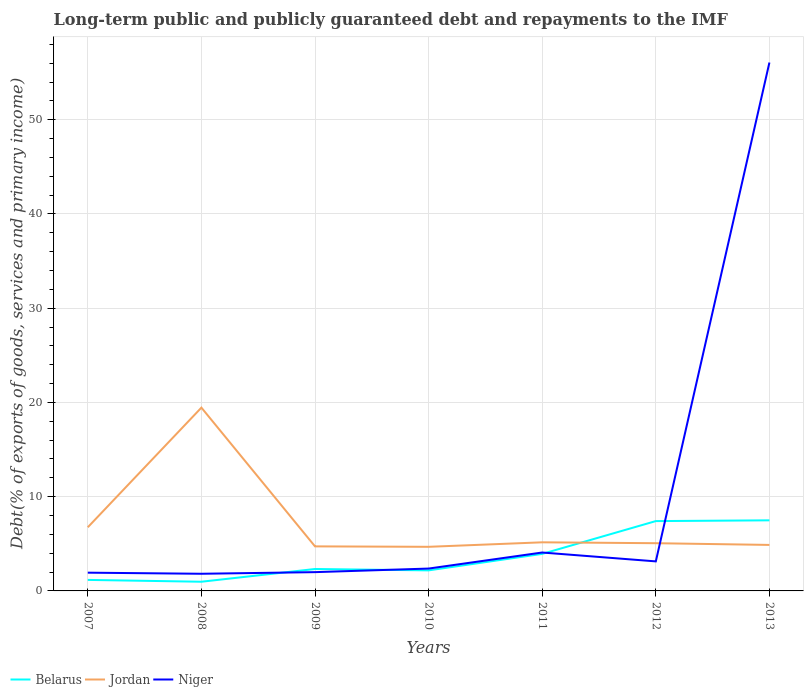How many different coloured lines are there?
Provide a short and direct response. 3. Does the line corresponding to Niger intersect with the line corresponding to Jordan?
Make the answer very short. Yes. Is the number of lines equal to the number of legend labels?
Make the answer very short. Yes. Across all years, what is the maximum debt and repayments in Niger?
Your answer should be very brief. 1.82. What is the total debt and repayments in Jordan in the graph?
Offer a terse response. 14.38. What is the difference between the highest and the second highest debt and repayments in Niger?
Provide a succinct answer. 54.25. What is the difference between the highest and the lowest debt and repayments in Belarus?
Make the answer very short. 3. Is the debt and repayments in Niger strictly greater than the debt and repayments in Belarus over the years?
Offer a terse response. No. How many years are there in the graph?
Your answer should be compact. 7. What is the difference between two consecutive major ticks on the Y-axis?
Provide a short and direct response. 10. Does the graph contain grids?
Offer a very short reply. Yes. Where does the legend appear in the graph?
Give a very brief answer. Bottom left. How many legend labels are there?
Ensure brevity in your answer.  3. What is the title of the graph?
Your response must be concise. Long-term public and publicly guaranteed debt and repayments to the IMF. What is the label or title of the Y-axis?
Ensure brevity in your answer.  Debt(% of exports of goods, services and primary income). What is the Debt(% of exports of goods, services and primary income) in Belarus in 2007?
Your answer should be compact. 1.17. What is the Debt(% of exports of goods, services and primary income) of Jordan in 2007?
Offer a very short reply. 6.75. What is the Debt(% of exports of goods, services and primary income) in Niger in 2007?
Provide a short and direct response. 1.94. What is the Debt(% of exports of goods, services and primary income) of Belarus in 2008?
Your response must be concise. 0.98. What is the Debt(% of exports of goods, services and primary income) of Jordan in 2008?
Offer a very short reply. 19.45. What is the Debt(% of exports of goods, services and primary income) in Niger in 2008?
Your answer should be very brief. 1.82. What is the Debt(% of exports of goods, services and primary income) in Belarus in 2009?
Ensure brevity in your answer.  2.33. What is the Debt(% of exports of goods, services and primary income) in Jordan in 2009?
Ensure brevity in your answer.  4.73. What is the Debt(% of exports of goods, services and primary income) in Niger in 2009?
Offer a very short reply. 1.99. What is the Debt(% of exports of goods, services and primary income) in Belarus in 2010?
Offer a very short reply. 2.18. What is the Debt(% of exports of goods, services and primary income) of Jordan in 2010?
Ensure brevity in your answer.  4.68. What is the Debt(% of exports of goods, services and primary income) of Niger in 2010?
Make the answer very short. 2.37. What is the Debt(% of exports of goods, services and primary income) in Belarus in 2011?
Make the answer very short. 3.93. What is the Debt(% of exports of goods, services and primary income) of Jordan in 2011?
Your response must be concise. 5.16. What is the Debt(% of exports of goods, services and primary income) in Niger in 2011?
Your answer should be very brief. 4.08. What is the Debt(% of exports of goods, services and primary income) in Belarus in 2012?
Provide a succinct answer. 7.41. What is the Debt(% of exports of goods, services and primary income) of Jordan in 2012?
Keep it short and to the point. 5.06. What is the Debt(% of exports of goods, services and primary income) in Niger in 2012?
Offer a terse response. 3.13. What is the Debt(% of exports of goods, services and primary income) in Belarus in 2013?
Provide a succinct answer. 7.49. What is the Debt(% of exports of goods, services and primary income) of Jordan in 2013?
Your answer should be very brief. 4.88. What is the Debt(% of exports of goods, services and primary income) of Niger in 2013?
Make the answer very short. 56.07. Across all years, what is the maximum Debt(% of exports of goods, services and primary income) of Belarus?
Make the answer very short. 7.49. Across all years, what is the maximum Debt(% of exports of goods, services and primary income) of Jordan?
Ensure brevity in your answer.  19.45. Across all years, what is the maximum Debt(% of exports of goods, services and primary income) of Niger?
Make the answer very short. 56.07. Across all years, what is the minimum Debt(% of exports of goods, services and primary income) of Belarus?
Offer a terse response. 0.98. Across all years, what is the minimum Debt(% of exports of goods, services and primary income) of Jordan?
Provide a short and direct response. 4.68. Across all years, what is the minimum Debt(% of exports of goods, services and primary income) of Niger?
Make the answer very short. 1.82. What is the total Debt(% of exports of goods, services and primary income) in Belarus in the graph?
Your answer should be compact. 25.48. What is the total Debt(% of exports of goods, services and primary income) of Jordan in the graph?
Ensure brevity in your answer.  50.71. What is the total Debt(% of exports of goods, services and primary income) in Niger in the graph?
Give a very brief answer. 71.4. What is the difference between the Debt(% of exports of goods, services and primary income) of Belarus in 2007 and that in 2008?
Ensure brevity in your answer.  0.19. What is the difference between the Debt(% of exports of goods, services and primary income) in Jordan in 2007 and that in 2008?
Make the answer very short. -12.7. What is the difference between the Debt(% of exports of goods, services and primary income) of Niger in 2007 and that in 2008?
Offer a very short reply. 0.12. What is the difference between the Debt(% of exports of goods, services and primary income) in Belarus in 2007 and that in 2009?
Your response must be concise. -1.16. What is the difference between the Debt(% of exports of goods, services and primary income) of Jordan in 2007 and that in 2009?
Offer a terse response. 2.03. What is the difference between the Debt(% of exports of goods, services and primary income) of Niger in 2007 and that in 2009?
Keep it short and to the point. -0.06. What is the difference between the Debt(% of exports of goods, services and primary income) in Belarus in 2007 and that in 2010?
Give a very brief answer. -1.01. What is the difference between the Debt(% of exports of goods, services and primary income) in Jordan in 2007 and that in 2010?
Offer a very short reply. 2.07. What is the difference between the Debt(% of exports of goods, services and primary income) in Niger in 2007 and that in 2010?
Offer a terse response. -0.44. What is the difference between the Debt(% of exports of goods, services and primary income) in Belarus in 2007 and that in 2011?
Keep it short and to the point. -2.76. What is the difference between the Debt(% of exports of goods, services and primary income) of Jordan in 2007 and that in 2011?
Make the answer very short. 1.6. What is the difference between the Debt(% of exports of goods, services and primary income) in Niger in 2007 and that in 2011?
Give a very brief answer. -2.14. What is the difference between the Debt(% of exports of goods, services and primary income) of Belarus in 2007 and that in 2012?
Your response must be concise. -6.24. What is the difference between the Debt(% of exports of goods, services and primary income) of Jordan in 2007 and that in 2012?
Your answer should be compact. 1.69. What is the difference between the Debt(% of exports of goods, services and primary income) of Niger in 2007 and that in 2012?
Offer a very short reply. -1.2. What is the difference between the Debt(% of exports of goods, services and primary income) of Belarus in 2007 and that in 2013?
Offer a very short reply. -6.32. What is the difference between the Debt(% of exports of goods, services and primary income) of Jordan in 2007 and that in 2013?
Your response must be concise. 1.87. What is the difference between the Debt(% of exports of goods, services and primary income) of Niger in 2007 and that in 2013?
Give a very brief answer. -54.13. What is the difference between the Debt(% of exports of goods, services and primary income) of Belarus in 2008 and that in 2009?
Give a very brief answer. -1.35. What is the difference between the Debt(% of exports of goods, services and primary income) in Jordan in 2008 and that in 2009?
Provide a succinct answer. 14.72. What is the difference between the Debt(% of exports of goods, services and primary income) in Niger in 2008 and that in 2009?
Provide a succinct answer. -0.17. What is the difference between the Debt(% of exports of goods, services and primary income) of Belarus in 2008 and that in 2010?
Provide a succinct answer. -1.21. What is the difference between the Debt(% of exports of goods, services and primary income) of Jordan in 2008 and that in 2010?
Keep it short and to the point. 14.77. What is the difference between the Debt(% of exports of goods, services and primary income) in Niger in 2008 and that in 2010?
Offer a terse response. -0.55. What is the difference between the Debt(% of exports of goods, services and primary income) of Belarus in 2008 and that in 2011?
Ensure brevity in your answer.  -2.96. What is the difference between the Debt(% of exports of goods, services and primary income) of Jordan in 2008 and that in 2011?
Offer a terse response. 14.29. What is the difference between the Debt(% of exports of goods, services and primary income) in Niger in 2008 and that in 2011?
Keep it short and to the point. -2.26. What is the difference between the Debt(% of exports of goods, services and primary income) in Belarus in 2008 and that in 2012?
Offer a terse response. -6.44. What is the difference between the Debt(% of exports of goods, services and primary income) in Jordan in 2008 and that in 2012?
Offer a very short reply. 14.38. What is the difference between the Debt(% of exports of goods, services and primary income) of Niger in 2008 and that in 2012?
Your answer should be compact. -1.31. What is the difference between the Debt(% of exports of goods, services and primary income) in Belarus in 2008 and that in 2013?
Ensure brevity in your answer.  -6.52. What is the difference between the Debt(% of exports of goods, services and primary income) in Jordan in 2008 and that in 2013?
Your response must be concise. 14.57. What is the difference between the Debt(% of exports of goods, services and primary income) in Niger in 2008 and that in 2013?
Keep it short and to the point. -54.25. What is the difference between the Debt(% of exports of goods, services and primary income) in Belarus in 2009 and that in 2010?
Give a very brief answer. 0.15. What is the difference between the Debt(% of exports of goods, services and primary income) of Jordan in 2009 and that in 2010?
Provide a short and direct response. 0.05. What is the difference between the Debt(% of exports of goods, services and primary income) in Niger in 2009 and that in 2010?
Make the answer very short. -0.38. What is the difference between the Debt(% of exports of goods, services and primary income) of Belarus in 2009 and that in 2011?
Offer a terse response. -1.6. What is the difference between the Debt(% of exports of goods, services and primary income) of Jordan in 2009 and that in 2011?
Give a very brief answer. -0.43. What is the difference between the Debt(% of exports of goods, services and primary income) in Niger in 2009 and that in 2011?
Make the answer very short. -2.08. What is the difference between the Debt(% of exports of goods, services and primary income) in Belarus in 2009 and that in 2012?
Your response must be concise. -5.08. What is the difference between the Debt(% of exports of goods, services and primary income) of Jordan in 2009 and that in 2012?
Your answer should be compact. -0.34. What is the difference between the Debt(% of exports of goods, services and primary income) of Niger in 2009 and that in 2012?
Offer a very short reply. -1.14. What is the difference between the Debt(% of exports of goods, services and primary income) of Belarus in 2009 and that in 2013?
Your answer should be compact. -5.16. What is the difference between the Debt(% of exports of goods, services and primary income) in Jordan in 2009 and that in 2013?
Your answer should be compact. -0.15. What is the difference between the Debt(% of exports of goods, services and primary income) of Niger in 2009 and that in 2013?
Keep it short and to the point. -54.08. What is the difference between the Debt(% of exports of goods, services and primary income) in Belarus in 2010 and that in 2011?
Offer a terse response. -1.75. What is the difference between the Debt(% of exports of goods, services and primary income) in Jordan in 2010 and that in 2011?
Offer a very short reply. -0.48. What is the difference between the Debt(% of exports of goods, services and primary income) of Niger in 2010 and that in 2011?
Ensure brevity in your answer.  -1.7. What is the difference between the Debt(% of exports of goods, services and primary income) in Belarus in 2010 and that in 2012?
Give a very brief answer. -5.23. What is the difference between the Debt(% of exports of goods, services and primary income) in Jordan in 2010 and that in 2012?
Ensure brevity in your answer.  -0.38. What is the difference between the Debt(% of exports of goods, services and primary income) of Niger in 2010 and that in 2012?
Offer a very short reply. -0.76. What is the difference between the Debt(% of exports of goods, services and primary income) of Belarus in 2010 and that in 2013?
Ensure brevity in your answer.  -5.31. What is the difference between the Debt(% of exports of goods, services and primary income) of Jordan in 2010 and that in 2013?
Offer a terse response. -0.2. What is the difference between the Debt(% of exports of goods, services and primary income) of Niger in 2010 and that in 2013?
Your answer should be very brief. -53.7. What is the difference between the Debt(% of exports of goods, services and primary income) in Belarus in 2011 and that in 2012?
Keep it short and to the point. -3.48. What is the difference between the Debt(% of exports of goods, services and primary income) in Jordan in 2011 and that in 2012?
Your answer should be compact. 0.09. What is the difference between the Debt(% of exports of goods, services and primary income) in Niger in 2011 and that in 2012?
Offer a very short reply. 0.94. What is the difference between the Debt(% of exports of goods, services and primary income) of Belarus in 2011 and that in 2013?
Offer a terse response. -3.56. What is the difference between the Debt(% of exports of goods, services and primary income) in Jordan in 2011 and that in 2013?
Ensure brevity in your answer.  0.28. What is the difference between the Debt(% of exports of goods, services and primary income) of Niger in 2011 and that in 2013?
Provide a short and direct response. -51.99. What is the difference between the Debt(% of exports of goods, services and primary income) in Belarus in 2012 and that in 2013?
Offer a terse response. -0.08. What is the difference between the Debt(% of exports of goods, services and primary income) of Jordan in 2012 and that in 2013?
Make the answer very short. 0.18. What is the difference between the Debt(% of exports of goods, services and primary income) of Niger in 2012 and that in 2013?
Ensure brevity in your answer.  -52.93. What is the difference between the Debt(% of exports of goods, services and primary income) of Belarus in 2007 and the Debt(% of exports of goods, services and primary income) of Jordan in 2008?
Provide a succinct answer. -18.28. What is the difference between the Debt(% of exports of goods, services and primary income) in Belarus in 2007 and the Debt(% of exports of goods, services and primary income) in Niger in 2008?
Provide a short and direct response. -0.65. What is the difference between the Debt(% of exports of goods, services and primary income) of Jordan in 2007 and the Debt(% of exports of goods, services and primary income) of Niger in 2008?
Keep it short and to the point. 4.93. What is the difference between the Debt(% of exports of goods, services and primary income) of Belarus in 2007 and the Debt(% of exports of goods, services and primary income) of Jordan in 2009?
Provide a succinct answer. -3.56. What is the difference between the Debt(% of exports of goods, services and primary income) of Belarus in 2007 and the Debt(% of exports of goods, services and primary income) of Niger in 2009?
Give a very brief answer. -0.82. What is the difference between the Debt(% of exports of goods, services and primary income) of Jordan in 2007 and the Debt(% of exports of goods, services and primary income) of Niger in 2009?
Provide a short and direct response. 4.76. What is the difference between the Debt(% of exports of goods, services and primary income) of Belarus in 2007 and the Debt(% of exports of goods, services and primary income) of Jordan in 2010?
Your response must be concise. -3.51. What is the difference between the Debt(% of exports of goods, services and primary income) of Belarus in 2007 and the Debt(% of exports of goods, services and primary income) of Niger in 2010?
Ensure brevity in your answer.  -1.2. What is the difference between the Debt(% of exports of goods, services and primary income) in Jordan in 2007 and the Debt(% of exports of goods, services and primary income) in Niger in 2010?
Offer a terse response. 4.38. What is the difference between the Debt(% of exports of goods, services and primary income) of Belarus in 2007 and the Debt(% of exports of goods, services and primary income) of Jordan in 2011?
Offer a terse response. -3.99. What is the difference between the Debt(% of exports of goods, services and primary income) of Belarus in 2007 and the Debt(% of exports of goods, services and primary income) of Niger in 2011?
Provide a short and direct response. -2.91. What is the difference between the Debt(% of exports of goods, services and primary income) of Jordan in 2007 and the Debt(% of exports of goods, services and primary income) of Niger in 2011?
Your answer should be compact. 2.68. What is the difference between the Debt(% of exports of goods, services and primary income) in Belarus in 2007 and the Debt(% of exports of goods, services and primary income) in Jordan in 2012?
Your response must be concise. -3.9. What is the difference between the Debt(% of exports of goods, services and primary income) in Belarus in 2007 and the Debt(% of exports of goods, services and primary income) in Niger in 2012?
Give a very brief answer. -1.97. What is the difference between the Debt(% of exports of goods, services and primary income) of Jordan in 2007 and the Debt(% of exports of goods, services and primary income) of Niger in 2012?
Provide a short and direct response. 3.62. What is the difference between the Debt(% of exports of goods, services and primary income) in Belarus in 2007 and the Debt(% of exports of goods, services and primary income) in Jordan in 2013?
Offer a very short reply. -3.71. What is the difference between the Debt(% of exports of goods, services and primary income) in Belarus in 2007 and the Debt(% of exports of goods, services and primary income) in Niger in 2013?
Provide a short and direct response. -54.9. What is the difference between the Debt(% of exports of goods, services and primary income) of Jordan in 2007 and the Debt(% of exports of goods, services and primary income) of Niger in 2013?
Your answer should be compact. -49.32. What is the difference between the Debt(% of exports of goods, services and primary income) of Belarus in 2008 and the Debt(% of exports of goods, services and primary income) of Jordan in 2009?
Offer a terse response. -3.75. What is the difference between the Debt(% of exports of goods, services and primary income) in Belarus in 2008 and the Debt(% of exports of goods, services and primary income) in Niger in 2009?
Your answer should be compact. -1.02. What is the difference between the Debt(% of exports of goods, services and primary income) in Jordan in 2008 and the Debt(% of exports of goods, services and primary income) in Niger in 2009?
Your answer should be very brief. 17.46. What is the difference between the Debt(% of exports of goods, services and primary income) of Belarus in 2008 and the Debt(% of exports of goods, services and primary income) of Jordan in 2010?
Provide a succinct answer. -3.71. What is the difference between the Debt(% of exports of goods, services and primary income) of Belarus in 2008 and the Debt(% of exports of goods, services and primary income) of Niger in 2010?
Give a very brief answer. -1.4. What is the difference between the Debt(% of exports of goods, services and primary income) in Jordan in 2008 and the Debt(% of exports of goods, services and primary income) in Niger in 2010?
Your answer should be very brief. 17.08. What is the difference between the Debt(% of exports of goods, services and primary income) of Belarus in 2008 and the Debt(% of exports of goods, services and primary income) of Jordan in 2011?
Provide a succinct answer. -4.18. What is the difference between the Debt(% of exports of goods, services and primary income) of Belarus in 2008 and the Debt(% of exports of goods, services and primary income) of Niger in 2011?
Offer a very short reply. -3.1. What is the difference between the Debt(% of exports of goods, services and primary income) of Jordan in 2008 and the Debt(% of exports of goods, services and primary income) of Niger in 2011?
Your response must be concise. 15.37. What is the difference between the Debt(% of exports of goods, services and primary income) of Belarus in 2008 and the Debt(% of exports of goods, services and primary income) of Jordan in 2012?
Keep it short and to the point. -4.09. What is the difference between the Debt(% of exports of goods, services and primary income) in Belarus in 2008 and the Debt(% of exports of goods, services and primary income) in Niger in 2012?
Offer a terse response. -2.16. What is the difference between the Debt(% of exports of goods, services and primary income) in Jordan in 2008 and the Debt(% of exports of goods, services and primary income) in Niger in 2012?
Keep it short and to the point. 16.31. What is the difference between the Debt(% of exports of goods, services and primary income) in Belarus in 2008 and the Debt(% of exports of goods, services and primary income) in Jordan in 2013?
Offer a very short reply. -3.91. What is the difference between the Debt(% of exports of goods, services and primary income) of Belarus in 2008 and the Debt(% of exports of goods, services and primary income) of Niger in 2013?
Keep it short and to the point. -55.09. What is the difference between the Debt(% of exports of goods, services and primary income) in Jordan in 2008 and the Debt(% of exports of goods, services and primary income) in Niger in 2013?
Provide a short and direct response. -36.62. What is the difference between the Debt(% of exports of goods, services and primary income) of Belarus in 2009 and the Debt(% of exports of goods, services and primary income) of Jordan in 2010?
Provide a succinct answer. -2.35. What is the difference between the Debt(% of exports of goods, services and primary income) in Belarus in 2009 and the Debt(% of exports of goods, services and primary income) in Niger in 2010?
Offer a terse response. -0.05. What is the difference between the Debt(% of exports of goods, services and primary income) in Jordan in 2009 and the Debt(% of exports of goods, services and primary income) in Niger in 2010?
Make the answer very short. 2.35. What is the difference between the Debt(% of exports of goods, services and primary income) in Belarus in 2009 and the Debt(% of exports of goods, services and primary income) in Jordan in 2011?
Your answer should be compact. -2.83. What is the difference between the Debt(% of exports of goods, services and primary income) of Belarus in 2009 and the Debt(% of exports of goods, services and primary income) of Niger in 2011?
Give a very brief answer. -1.75. What is the difference between the Debt(% of exports of goods, services and primary income) of Jordan in 2009 and the Debt(% of exports of goods, services and primary income) of Niger in 2011?
Your response must be concise. 0.65. What is the difference between the Debt(% of exports of goods, services and primary income) of Belarus in 2009 and the Debt(% of exports of goods, services and primary income) of Jordan in 2012?
Provide a succinct answer. -2.74. What is the difference between the Debt(% of exports of goods, services and primary income) of Belarus in 2009 and the Debt(% of exports of goods, services and primary income) of Niger in 2012?
Your answer should be compact. -0.81. What is the difference between the Debt(% of exports of goods, services and primary income) of Jordan in 2009 and the Debt(% of exports of goods, services and primary income) of Niger in 2012?
Make the answer very short. 1.59. What is the difference between the Debt(% of exports of goods, services and primary income) of Belarus in 2009 and the Debt(% of exports of goods, services and primary income) of Jordan in 2013?
Offer a terse response. -2.56. What is the difference between the Debt(% of exports of goods, services and primary income) of Belarus in 2009 and the Debt(% of exports of goods, services and primary income) of Niger in 2013?
Make the answer very short. -53.74. What is the difference between the Debt(% of exports of goods, services and primary income) of Jordan in 2009 and the Debt(% of exports of goods, services and primary income) of Niger in 2013?
Give a very brief answer. -51.34. What is the difference between the Debt(% of exports of goods, services and primary income) in Belarus in 2010 and the Debt(% of exports of goods, services and primary income) in Jordan in 2011?
Provide a short and direct response. -2.98. What is the difference between the Debt(% of exports of goods, services and primary income) in Belarus in 2010 and the Debt(% of exports of goods, services and primary income) in Niger in 2011?
Your response must be concise. -1.89. What is the difference between the Debt(% of exports of goods, services and primary income) of Jordan in 2010 and the Debt(% of exports of goods, services and primary income) of Niger in 2011?
Offer a very short reply. 0.6. What is the difference between the Debt(% of exports of goods, services and primary income) of Belarus in 2010 and the Debt(% of exports of goods, services and primary income) of Jordan in 2012?
Offer a terse response. -2.88. What is the difference between the Debt(% of exports of goods, services and primary income) in Belarus in 2010 and the Debt(% of exports of goods, services and primary income) in Niger in 2012?
Ensure brevity in your answer.  -0.95. What is the difference between the Debt(% of exports of goods, services and primary income) of Jordan in 2010 and the Debt(% of exports of goods, services and primary income) of Niger in 2012?
Your answer should be compact. 1.55. What is the difference between the Debt(% of exports of goods, services and primary income) in Belarus in 2010 and the Debt(% of exports of goods, services and primary income) in Jordan in 2013?
Your response must be concise. -2.7. What is the difference between the Debt(% of exports of goods, services and primary income) in Belarus in 2010 and the Debt(% of exports of goods, services and primary income) in Niger in 2013?
Provide a succinct answer. -53.89. What is the difference between the Debt(% of exports of goods, services and primary income) of Jordan in 2010 and the Debt(% of exports of goods, services and primary income) of Niger in 2013?
Your answer should be compact. -51.39. What is the difference between the Debt(% of exports of goods, services and primary income) of Belarus in 2011 and the Debt(% of exports of goods, services and primary income) of Jordan in 2012?
Ensure brevity in your answer.  -1.13. What is the difference between the Debt(% of exports of goods, services and primary income) in Belarus in 2011 and the Debt(% of exports of goods, services and primary income) in Niger in 2012?
Provide a succinct answer. 0.8. What is the difference between the Debt(% of exports of goods, services and primary income) in Jordan in 2011 and the Debt(% of exports of goods, services and primary income) in Niger in 2012?
Give a very brief answer. 2.02. What is the difference between the Debt(% of exports of goods, services and primary income) in Belarus in 2011 and the Debt(% of exports of goods, services and primary income) in Jordan in 2013?
Provide a short and direct response. -0.95. What is the difference between the Debt(% of exports of goods, services and primary income) in Belarus in 2011 and the Debt(% of exports of goods, services and primary income) in Niger in 2013?
Make the answer very short. -52.14. What is the difference between the Debt(% of exports of goods, services and primary income) in Jordan in 2011 and the Debt(% of exports of goods, services and primary income) in Niger in 2013?
Keep it short and to the point. -50.91. What is the difference between the Debt(% of exports of goods, services and primary income) in Belarus in 2012 and the Debt(% of exports of goods, services and primary income) in Jordan in 2013?
Your answer should be compact. 2.53. What is the difference between the Debt(% of exports of goods, services and primary income) in Belarus in 2012 and the Debt(% of exports of goods, services and primary income) in Niger in 2013?
Offer a very short reply. -48.66. What is the difference between the Debt(% of exports of goods, services and primary income) of Jordan in 2012 and the Debt(% of exports of goods, services and primary income) of Niger in 2013?
Your response must be concise. -51. What is the average Debt(% of exports of goods, services and primary income) in Belarus per year?
Your answer should be compact. 3.64. What is the average Debt(% of exports of goods, services and primary income) in Jordan per year?
Offer a very short reply. 7.24. What is the average Debt(% of exports of goods, services and primary income) in Niger per year?
Keep it short and to the point. 10.2. In the year 2007, what is the difference between the Debt(% of exports of goods, services and primary income) of Belarus and Debt(% of exports of goods, services and primary income) of Jordan?
Your answer should be very brief. -5.58. In the year 2007, what is the difference between the Debt(% of exports of goods, services and primary income) in Belarus and Debt(% of exports of goods, services and primary income) in Niger?
Your answer should be very brief. -0.77. In the year 2007, what is the difference between the Debt(% of exports of goods, services and primary income) of Jordan and Debt(% of exports of goods, services and primary income) of Niger?
Offer a terse response. 4.82. In the year 2008, what is the difference between the Debt(% of exports of goods, services and primary income) in Belarus and Debt(% of exports of goods, services and primary income) in Jordan?
Offer a terse response. -18.47. In the year 2008, what is the difference between the Debt(% of exports of goods, services and primary income) of Belarus and Debt(% of exports of goods, services and primary income) of Niger?
Provide a short and direct response. -0.84. In the year 2008, what is the difference between the Debt(% of exports of goods, services and primary income) in Jordan and Debt(% of exports of goods, services and primary income) in Niger?
Your answer should be compact. 17.63. In the year 2009, what is the difference between the Debt(% of exports of goods, services and primary income) in Belarus and Debt(% of exports of goods, services and primary income) in Jordan?
Provide a short and direct response. -2.4. In the year 2009, what is the difference between the Debt(% of exports of goods, services and primary income) in Belarus and Debt(% of exports of goods, services and primary income) in Niger?
Keep it short and to the point. 0.33. In the year 2009, what is the difference between the Debt(% of exports of goods, services and primary income) in Jordan and Debt(% of exports of goods, services and primary income) in Niger?
Your answer should be compact. 2.73. In the year 2010, what is the difference between the Debt(% of exports of goods, services and primary income) of Belarus and Debt(% of exports of goods, services and primary income) of Jordan?
Your response must be concise. -2.5. In the year 2010, what is the difference between the Debt(% of exports of goods, services and primary income) in Belarus and Debt(% of exports of goods, services and primary income) in Niger?
Provide a succinct answer. -0.19. In the year 2010, what is the difference between the Debt(% of exports of goods, services and primary income) of Jordan and Debt(% of exports of goods, services and primary income) of Niger?
Your response must be concise. 2.31. In the year 2011, what is the difference between the Debt(% of exports of goods, services and primary income) of Belarus and Debt(% of exports of goods, services and primary income) of Jordan?
Make the answer very short. -1.23. In the year 2011, what is the difference between the Debt(% of exports of goods, services and primary income) of Belarus and Debt(% of exports of goods, services and primary income) of Niger?
Keep it short and to the point. -0.15. In the year 2011, what is the difference between the Debt(% of exports of goods, services and primary income) in Jordan and Debt(% of exports of goods, services and primary income) in Niger?
Provide a succinct answer. 1.08. In the year 2012, what is the difference between the Debt(% of exports of goods, services and primary income) in Belarus and Debt(% of exports of goods, services and primary income) in Jordan?
Your answer should be very brief. 2.35. In the year 2012, what is the difference between the Debt(% of exports of goods, services and primary income) in Belarus and Debt(% of exports of goods, services and primary income) in Niger?
Offer a terse response. 4.28. In the year 2012, what is the difference between the Debt(% of exports of goods, services and primary income) of Jordan and Debt(% of exports of goods, services and primary income) of Niger?
Keep it short and to the point. 1.93. In the year 2013, what is the difference between the Debt(% of exports of goods, services and primary income) in Belarus and Debt(% of exports of goods, services and primary income) in Jordan?
Keep it short and to the point. 2.61. In the year 2013, what is the difference between the Debt(% of exports of goods, services and primary income) of Belarus and Debt(% of exports of goods, services and primary income) of Niger?
Provide a succinct answer. -48.58. In the year 2013, what is the difference between the Debt(% of exports of goods, services and primary income) in Jordan and Debt(% of exports of goods, services and primary income) in Niger?
Your response must be concise. -51.19. What is the ratio of the Debt(% of exports of goods, services and primary income) of Belarus in 2007 to that in 2008?
Keep it short and to the point. 1.2. What is the ratio of the Debt(% of exports of goods, services and primary income) in Jordan in 2007 to that in 2008?
Your answer should be compact. 0.35. What is the ratio of the Debt(% of exports of goods, services and primary income) of Niger in 2007 to that in 2008?
Keep it short and to the point. 1.06. What is the ratio of the Debt(% of exports of goods, services and primary income) in Belarus in 2007 to that in 2009?
Offer a very short reply. 0.5. What is the ratio of the Debt(% of exports of goods, services and primary income) of Jordan in 2007 to that in 2009?
Your answer should be very brief. 1.43. What is the ratio of the Debt(% of exports of goods, services and primary income) of Niger in 2007 to that in 2009?
Offer a very short reply. 0.97. What is the ratio of the Debt(% of exports of goods, services and primary income) of Belarus in 2007 to that in 2010?
Ensure brevity in your answer.  0.54. What is the ratio of the Debt(% of exports of goods, services and primary income) of Jordan in 2007 to that in 2010?
Give a very brief answer. 1.44. What is the ratio of the Debt(% of exports of goods, services and primary income) in Niger in 2007 to that in 2010?
Your response must be concise. 0.82. What is the ratio of the Debt(% of exports of goods, services and primary income) of Belarus in 2007 to that in 2011?
Your answer should be very brief. 0.3. What is the ratio of the Debt(% of exports of goods, services and primary income) in Jordan in 2007 to that in 2011?
Your answer should be very brief. 1.31. What is the ratio of the Debt(% of exports of goods, services and primary income) in Niger in 2007 to that in 2011?
Your answer should be compact. 0.48. What is the ratio of the Debt(% of exports of goods, services and primary income) in Belarus in 2007 to that in 2012?
Your response must be concise. 0.16. What is the ratio of the Debt(% of exports of goods, services and primary income) in Jordan in 2007 to that in 2012?
Your answer should be compact. 1.33. What is the ratio of the Debt(% of exports of goods, services and primary income) in Niger in 2007 to that in 2012?
Ensure brevity in your answer.  0.62. What is the ratio of the Debt(% of exports of goods, services and primary income) of Belarus in 2007 to that in 2013?
Provide a short and direct response. 0.16. What is the ratio of the Debt(% of exports of goods, services and primary income) in Jordan in 2007 to that in 2013?
Offer a very short reply. 1.38. What is the ratio of the Debt(% of exports of goods, services and primary income) in Niger in 2007 to that in 2013?
Offer a terse response. 0.03. What is the ratio of the Debt(% of exports of goods, services and primary income) of Belarus in 2008 to that in 2009?
Your response must be concise. 0.42. What is the ratio of the Debt(% of exports of goods, services and primary income) in Jordan in 2008 to that in 2009?
Your response must be concise. 4.11. What is the ratio of the Debt(% of exports of goods, services and primary income) in Niger in 2008 to that in 2009?
Make the answer very short. 0.91. What is the ratio of the Debt(% of exports of goods, services and primary income) of Belarus in 2008 to that in 2010?
Provide a short and direct response. 0.45. What is the ratio of the Debt(% of exports of goods, services and primary income) in Jordan in 2008 to that in 2010?
Provide a short and direct response. 4.16. What is the ratio of the Debt(% of exports of goods, services and primary income) in Niger in 2008 to that in 2010?
Your response must be concise. 0.77. What is the ratio of the Debt(% of exports of goods, services and primary income) in Belarus in 2008 to that in 2011?
Your answer should be compact. 0.25. What is the ratio of the Debt(% of exports of goods, services and primary income) in Jordan in 2008 to that in 2011?
Your response must be concise. 3.77. What is the ratio of the Debt(% of exports of goods, services and primary income) of Niger in 2008 to that in 2011?
Give a very brief answer. 0.45. What is the ratio of the Debt(% of exports of goods, services and primary income) in Belarus in 2008 to that in 2012?
Provide a succinct answer. 0.13. What is the ratio of the Debt(% of exports of goods, services and primary income) of Jordan in 2008 to that in 2012?
Offer a very short reply. 3.84. What is the ratio of the Debt(% of exports of goods, services and primary income) in Niger in 2008 to that in 2012?
Offer a very short reply. 0.58. What is the ratio of the Debt(% of exports of goods, services and primary income) in Belarus in 2008 to that in 2013?
Make the answer very short. 0.13. What is the ratio of the Debt(% of exports of goods, services and primary income) in Jordan in 2008 to that in 2013?
Your answer should be compact. 3.98. What is the ratio of the Debt(% of exports of goods, services and primary income) in Niger in 2008 to that in 2013?
Keep it short and to the point. 0.03. What is the ratio of the Debt(% of exports of goods, services and primary income) of Belarus in 2009 to that in 2010?
Ensure brevity in your answer.  1.07. What is the ratio of the Debt(% of exports of goods, services and primary income) in Jordan in 2009 to that in 2010?
Make the answer very short. 1.01. What is the ratio of the Debt(% of exports of goods, services and primary income) in Niger in 2009 to that in 2010?
Your answer should be compact. 0.84. What is the ratio of the Debt(% of exports of goods, services and primary income) in Belarus in 2009 to that in 2011?
Provide a succinct answer. 0.59. What is the ratio of the Debt(% of exports of goods, services and primary income) of Jordan in 2009 to that in 2011?
Give a very brief answer. 0.92. What is the ratio of the Debt(% of exports of goods, services and primary income) of Niger in 2009 to that in 2011?
Provide a succinct answer. 0.49. What is the ratio of the Debt(% of exports of goods, services and primary income) of Belarus in 2009 to that in 2012?
Your answer should be very brief. 0.31. What is the ratio of the Debt(% of exports of goods, services and primary income) of Jordan in 2009 to that in 2012?
Provide a short and direct response. 0.93. What is the ratio of the Debt(% of exports of goods, services and primary income) in Niger in 2009 to that in 2012?
Offer a very short reply. 0.64. What is the ratio of the Debt(% of exports of goods, services and primary income) of Belarus in 2009 to that in 2013?
Ensure brevity in your answer.  0.31. What is the ratio of the Debt(% of exports of goods, services and primary income) in Jordan in 2009 to that in 2013?
Make the answer very short. 0.97. What is the ratio of the Debt(% of exports of goods, services and primary income) in Niger in 2009 to that in 2013?
Provide a succinct answer. 0.04. What is the ratio of the Debt(% of exports of goods, services and primary income) of Belarus in 2010 to that in 2011?
Your answer should be very brief. 0.55. What is the ratio of the Debt(% of exports of goods, services and primary income) of Jordan in 2010 to that in 2011?
Give a very brief answer. 0.91. What is the ratio of the Debt(% of exports of goods, services and primary income) of Niger in 2010 to that in 2011?
Make the answer very short. 0.58. What is the ratio of the Debt(% of exports of goods, services and primary income) of Belarus in 2010 to that in 2012?
Ensure brevity in your answer.  0.29. What is the ratio of the Debt(% of exports of goods, services and primary income) of Jordan in 2010 to that in 2012?
Offer a terse response. 0.92. What is the ratio of the Debt(% of exports of goods, services and primary income) of Niger in 2010 to that in 2012?
Give a very brief answer. 0.76. What is the ratio of the Debt(% of exports of goods, services and primary income) of Belarus in 2010 to that in 2013?
Make the answer very short. 0.29. What is the ratio of the Debt(% of exports of goods, services and primary income) of Jordan in 2010 to that in 2013?
Keep it short and to the point. 0.96. What is the ratio of the Debt(% of exports of goods, services and primary income) in Niger in 2010 to that in 2013?
Offer a very short reply. 0.04. What is the ratio of the Debt(% of exports of goods, services and primary income) of Belarus in 2011 to that in 2012?
Offer a very short reply. 0.53. What is the ratio of the Debt(% of exports of goods, services and primary income) of Jordan in 2011 to that in 2012?
Make the answer very short. 1.02. What is the ratio of the Debt(% of exports of goods, services and primary income) of Niger in 2011 to that in 2012?
Keep it short and to the point. 1.3. What is the ratio of the Debt(% of exports of goods, services and primary income) in Belarus in 2011 to that in 2013?
Your response must be concise. 0.52. What is the ratio of the Debt(% of exports of goods, services and primary income) in Jordan in 2011 to that in 2013?
Keep it short and to the point. 1.06. What is the ratio of the Debt(% of exports of goods, services and primary income) in Niger in 2011 to that in 2013?
Ensure brevity in your answer.  0.07. What is the ratio of the Debt(% of exports of goods, services and primary income) of Belarus in 2012 to that in 2013?
Make the answer very short. 0.99. What is the ratio of the Debt(% of exports of goods, services and primary income) in Jordan in 2012 to that in 2013?
Offer a terse response. 1.04. What is the ratio of the Debt(% of exports of goods, services and primary income) of Niger in 2012 to that in 2013?
Your answer should be compact. 0.06. What is the difference between the highest and the second highest Debt(% of exports of goods, services and primary income) of Belarus?
Keep it short and to the point. 0.08. What is the difference between the highest and the second highest Debt(% of exports of goods, services and primary income) of Jordan?
Ensure brevity in your answer.  12.7. What is the difference between the highest and the second highest Debt(% of exports of goods, services and primary income) in Niger?
Provide a succinct answer. 51.99. What is the difference between the highest and the lowest Debt(% of exports of goods, services and primary income) of Belarus?
Provide a succinct answer. 6.52. What is the difference between the highest and the lowest Debt(% of exports of goods, services and primary income) in Jordan?
Your answer should be compact. 14.77. What is the difference between the highest and the lowest Debt(% of exports of goods, services and primary income) of Niger?
Make the answer very short. 54.25. 